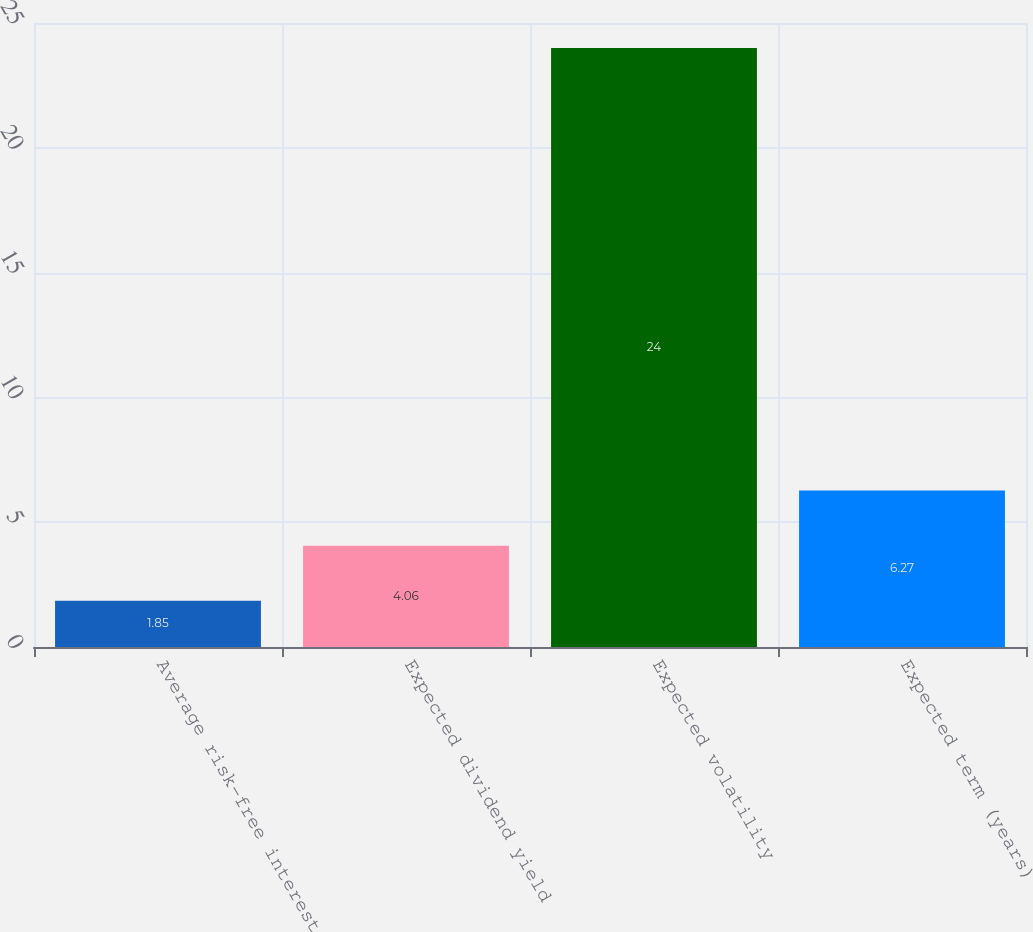Convert chart to OTSL. <chart><loc_0><loc_0><loc_500><loc_500><bar_chart><fcel>Average risk-free interest<fcel>Expected dividend yield<fcel>Expected volatility<fcel>Expected term (years)<nl><fcel>1.85<fcel>4.06<fcel>24<fcel>6.27<nl></chart> 